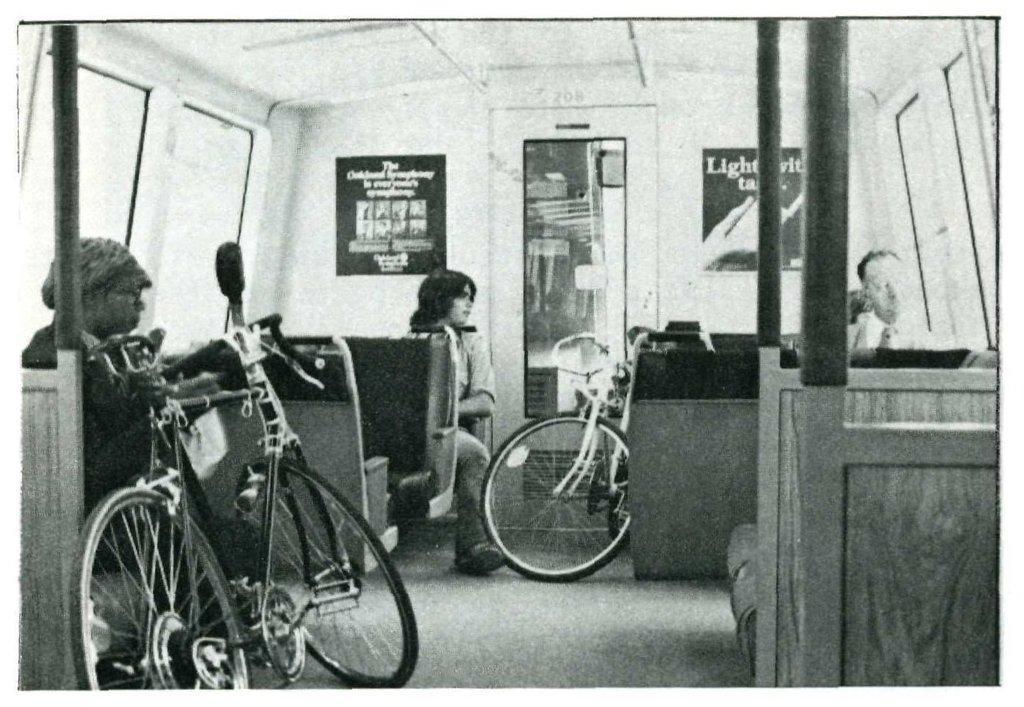Can you describe this image briefly? This image is taken from inside the vehicle. In this image there are a few people sitting in their seats, there are two bicycles, posters are attached to the wall of the vehicle, there is a glass door and windows. 